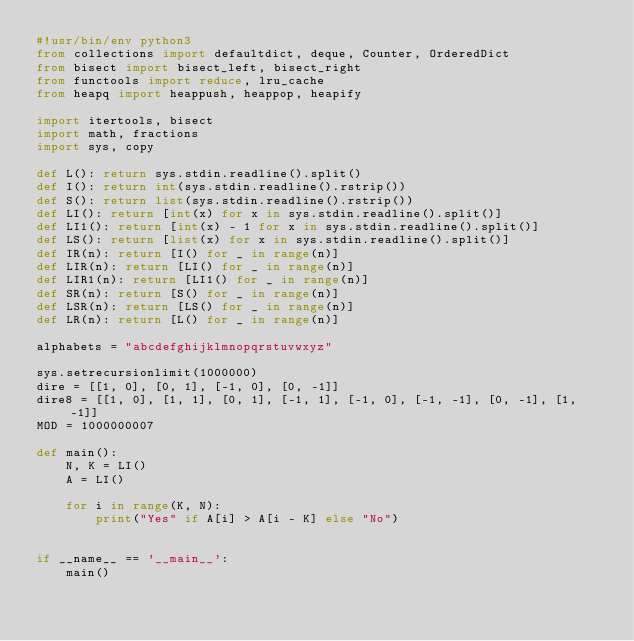Convert code to text. <code><loc_0><loc_0><loc_500><loc_500><_Python_>#!usr/bin/env python3
from collections import defaultdict, deque, Counter, OrderedDict
from bisect import bisect_left, bisect_right
from functools import reduce, lru_cache
from heapq import heappush, heappop, heapify

import itertools, bisect
import math, fractions
import sys, copy

def L(): return sys.stdin.readline().split()
def I(): return int(sys.stdin.readline().rstrip())
def S(): return list(sys.stdin.readline().rstrip())
def LI(): return [int(x) for x in sys.stdin.readline().split()]
def LI1(): return [int(x) - 1 for x in sys.stdin.readline().split()]
def LS(): return [list(x) for x in sys.stdin.readline().split()]
def IR(n): return [I() for _ in range(n)]
def LIR(n): return [LI() for _ in range(n)]
def LIR1(n): return [LI1() for _ in range(n)]
def SR(n): return [S() for _ in range(n)]
def LSR(n): return [LS() for _ in range(n)]
def LR(n): return [L() for _ in range(n)]

alphabets = "abcdefghijklmnopqrstuvwxyz"

sys.setrecursionlimit(1000000)
dire = [[1, 0], [0, 1], [-1, 0], [0, -1]]
dire8 = [[1, 0], [1, 1], [0, 1], [-1, 1], [-1, 0], [-1, -1], [0, -1], [1, -1]]
MOD = 1000000007

def main():
    N, K = LI()
    A = LI()

    for i in range(K, N):
        print("Yes" if A[i] > A[i - K] else "No")


if __name__ == '__main__':
    main()</code> 